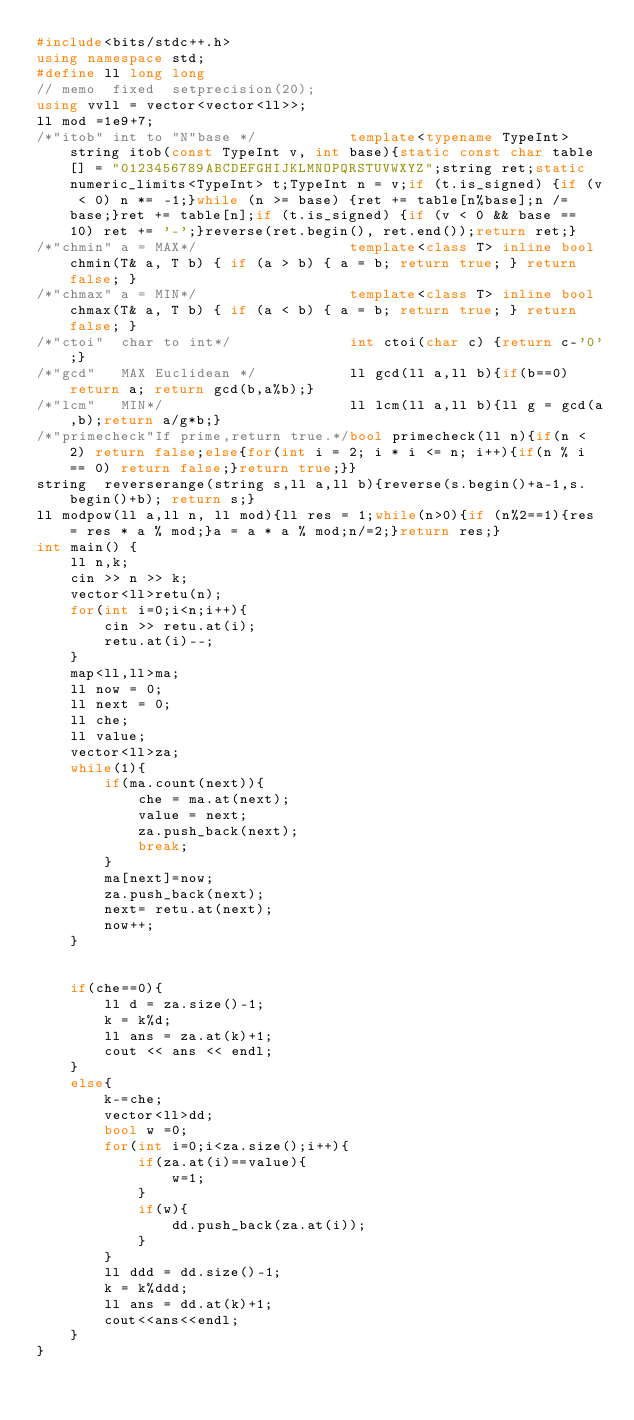Convert code to text. <code><loc_0><loc_0><loc_500><loc_500><_C++_>#include<bits/stdc++.h>
using namespace std;
#define ll long long 
// memo  fixed  setprecision(20);
using vvll = vector<vector<ll>>;
ll mod =1e9+7;
/*"itob" int to "N"base */           template<typename TypeInt> string itob(const TypeInt v, int base){static const char table[] = "0123456789ABCDEFGHIJKLMNOPQRSTUVWXYZ";string ret;static numeric_limits<TypeInt> t;TypeInt n = v;if (t.is_signed) {if (v < 0) n *= -1;}while (n >= base) {ret += table[n%base];n /= base;}ret += table[n];if (t.is_signed) {if (v < 0 && base == 10) ret += '-';}reverse(ret.begin(), ret.end());return ret;}
/*"chmin" a = MAX*/                  template<class T> inline bool chmin(T& a, T b) { if (a > b) { a = b; return true; } return false; }
/*"chmax" a = MIN*/                  template<class T> inline bool chmax(T& a, T b) { if (a < b) { a = b; return true; } return false; }
/*"ctoi"  char to int*/              int ctoi(char c) {return c-'0';}
/*"gcd"   MAX Euclidean */           ll gcd(ll a,ll b){if(b==0)return a; return gcd(b,a%b);}
/*"lcm"   MIN*/                      ll lcm(ll a,ll b){ll g = gcd(a,b);return a/g*b;}
/*"primecheck"If prime,return true.*/bool primecheck(ll n){if(n < 2) return false;else{for(int i = 2; i * i <= n; i++){if(n % i == 0) return false;}return true;}}
string  reverserange(string s,ll a,ll b){reverse(s.begin()+a-1,s.begin()+b); return s;}
ll modpow(ll a,ll n, ll mod){ll res = 1;while(n>0){if (n%2==1){res = res * a % mod;}a = a * a % mod;n/=2;}return res;}
int main() {
    ll n,k;
    cin >> n >> k;
    vector<ll>retu(n);
    for(int i=0;i<n;i++){
        cin >> retu.at(i);
        retu.at(i)--;
    }
    map<ll,ll>ma;
    ll now = 0;
    ll next = 0;
    ll che;
    ll value;
    vector<ll>za;
    while(1){
        if(ma.count(next)){
            che = ma.at(next);
            value = next;
            za.push_back(next);
            break;
        }
        ma[next]=now;
        za.push_back(next);
        next= retu.at(next);
        now++;
    }


    if(che==0){
        ll d = za.size()-1;
        k = k%d;
        ll ans = za.at(k)+1;
        cout << ans << endl;
    }
    else{
        k-=che;
        vector<ll>dd;
        bool w =0;
        for(int i=0;i<za.size();i++){
            if(za.at(i)==value){
                w=1;
            }
            if(w){
                dd.push_back(za.at(i));
            }
        }
        ll ddd = dd.size()-1;
        k = k%ddd;
        ll ans = dd.at(k)+1;
        cout<<ans<<endl;
    }
}
    

</code> 